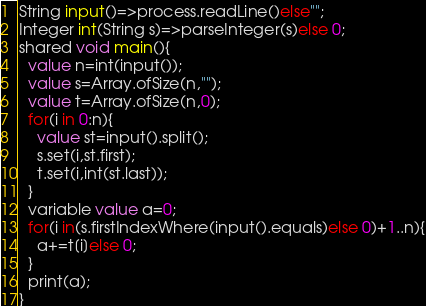Convert code to text. <code><loc_0><loc_0><loc_500><loc_500><_Ceylon_>String input()=>process.readLine()else""; 
Integer int(String s)=>parseInteger(s)else 0;
shared void main(){
  value n=int(input());
  value s=Array.ofSize(n,"");
  value t=Array.ofSize(n,0);
  for(i in 0:n){
    value st=input().split();
    s.set(i,st.first);
    t.set(i,int(st.last));
  }
  variable value a=0;
  for(i in(s.firstIndexWhere(input().equals)else 0)+1..n){
    a+=t[i]else 0;
  }
  print(a);
}</code> 